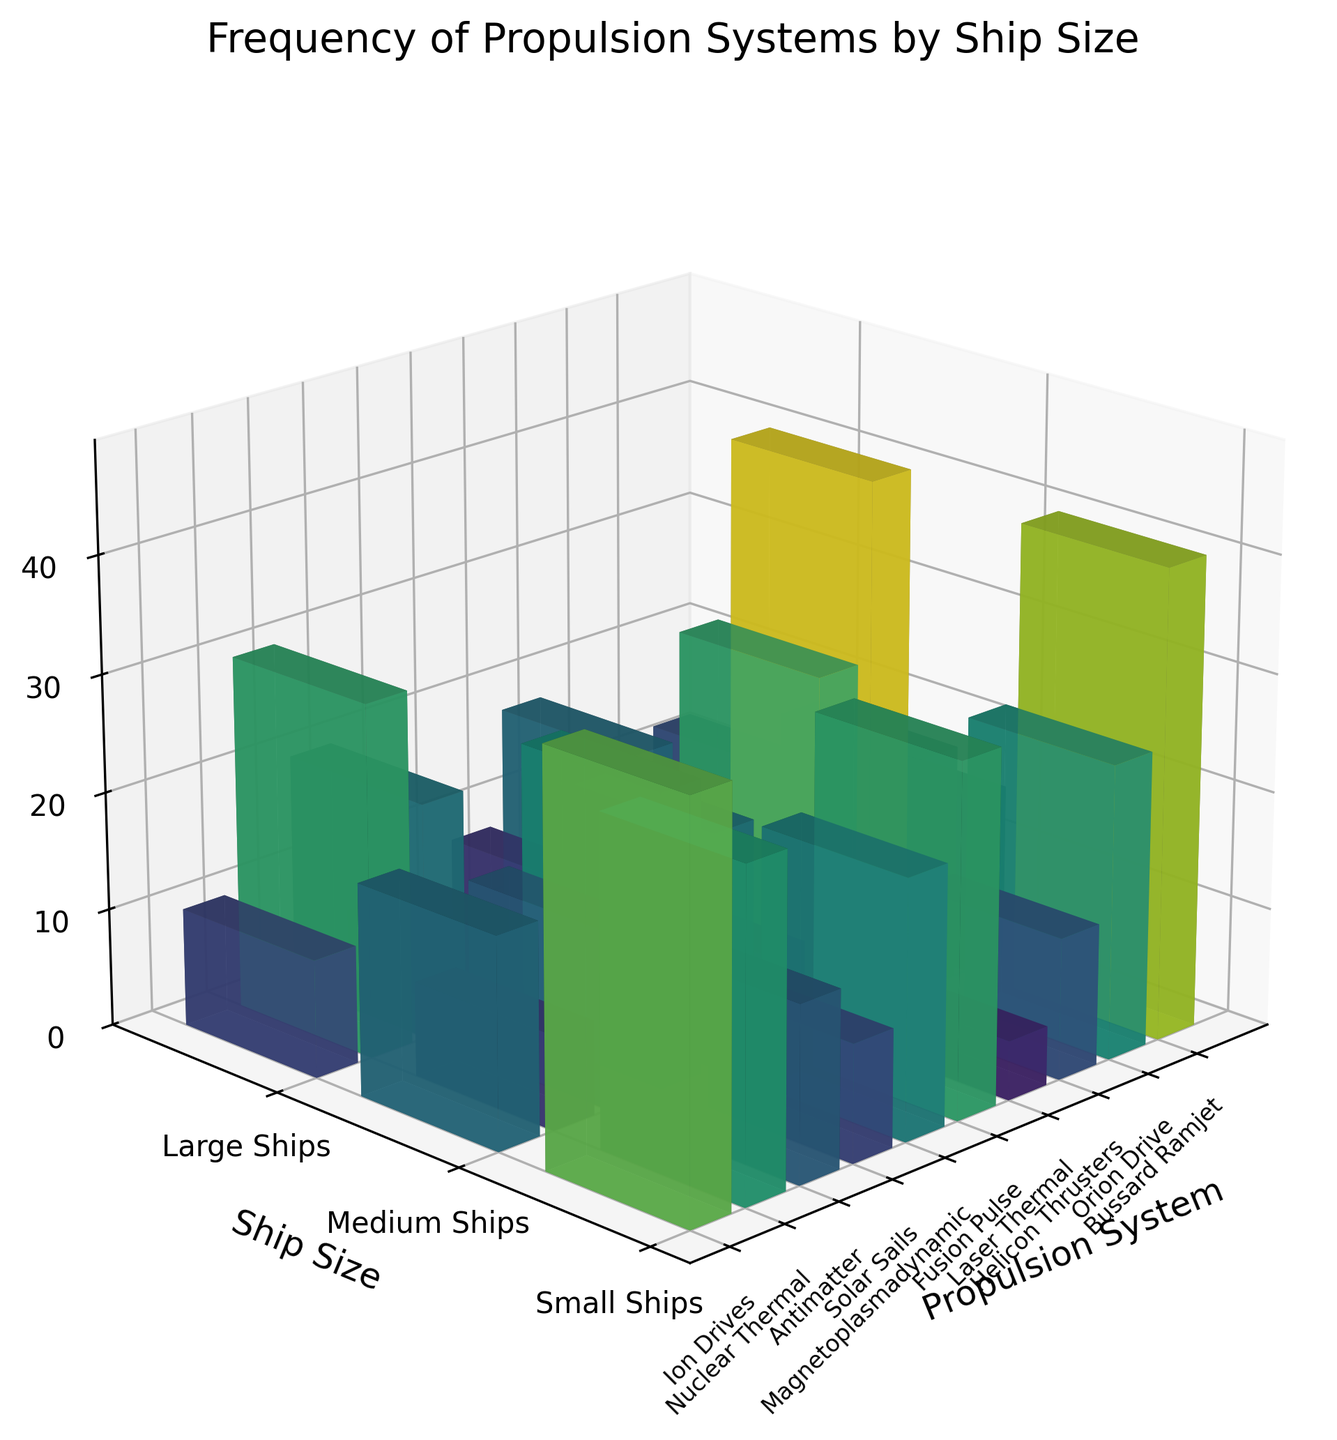What's the propulsion system with the highest frequency for small ships? To find the propulsion system with the highest frequency for small ships, look at the 'Small Ships' column in the plot and identify the tallest bar. The tallest bar among small ships corresponds to Solar Sails.
Answer: Solar Sails Which two propulsion systems tie for the highest frequency in large ships? To determine which two propulsion systems tie for the highest frequency in large ships, look at the 'Large Ships' column and observe the bar heights. Both Fusion Pulse and Nuclear Thermal have the tallest bars.
Answer: Fusion Pulse and Nuclear Thermal What is the total frequency of Antimatter propulsion across all ship sizes? To find the total frequency for Antimatter propulsion, sum up the frequencies for small, medium, and large ships. The values are 5 (small) + 12 (medium) + 25 (large) = 42.
Answer: 42 Compare the frequency of Helicon Thrusters and Orion Drive in medium ships. Which one is greater? Look at the 'Medium Ships' positions for Helicon Thrusters and Orion Drive and compare the heights. Helicon Thrusters have a frequency of 20, whereas Orion Drive has a frequency of 8, so Helicon Thrusters is greater.
Answer: Helicon Thrusters Which propulsion system has the lowest overall frequency in all ship sizes combined? To determine this, find the sum of frequencies for each propulsion system across all ship sizes and identify the lowest sum. Bussard Ramjet has 1 (small) + 5 (medium) + 12 (large) = 18, which is the lowest.
Answer: Bussard Ramjet What is the average frequency of Magnetoplasmadynamic propulsion across ship sizes? To get the average, sum the frequencies of Magnetoplasmadynamic propulsion for small, medium, and large ships and divide by 3. The values are 15 (small) + 25 (medium) + 20 (large) = 60, so the average is 60/3 = 20.
Answer: 20 Among small ships, which propulsion system has a frequency closest to 20? Look at the 'Small Ships' values and compare the frequencies to 20. Helicon Thrusters have a frequency of 30 and Laser Thermal has a frequency of 20, which is closest to 20.
Answer: Laser Thermal Is the frequency of Fusion Pulse propulsion in medium ships higher than the combined frequency of Solar Sails and Ion Drives in large ships? Compare the frequency of Fusion Pulse in medium ships (30) with the sum of Solar Sails and Ion Drives in large ships (8 + 15 = 23). Fusion Pulse in medium ships (30) is greater than the combined frequency of Solar Sails and Ion Drives in large ships (23).
Answer: Yes What's the difference in frequency between Laser Thermal propulsion in small ships and large ships? Subtract the frequency of Laser Thermal in large ships (10) from its frequency in small ships (20). The difference is 20 - 10 = 10.
Answer: 10 Which propulsion system's frequency decreases with increasing ship size? To find a system whose frequency decreases from small to medium to large ships, identify the trends in the bars. Solar Sails decrease from 40 (small) to 18 (medium) to 8 (large).
Answer: Solar Sails 